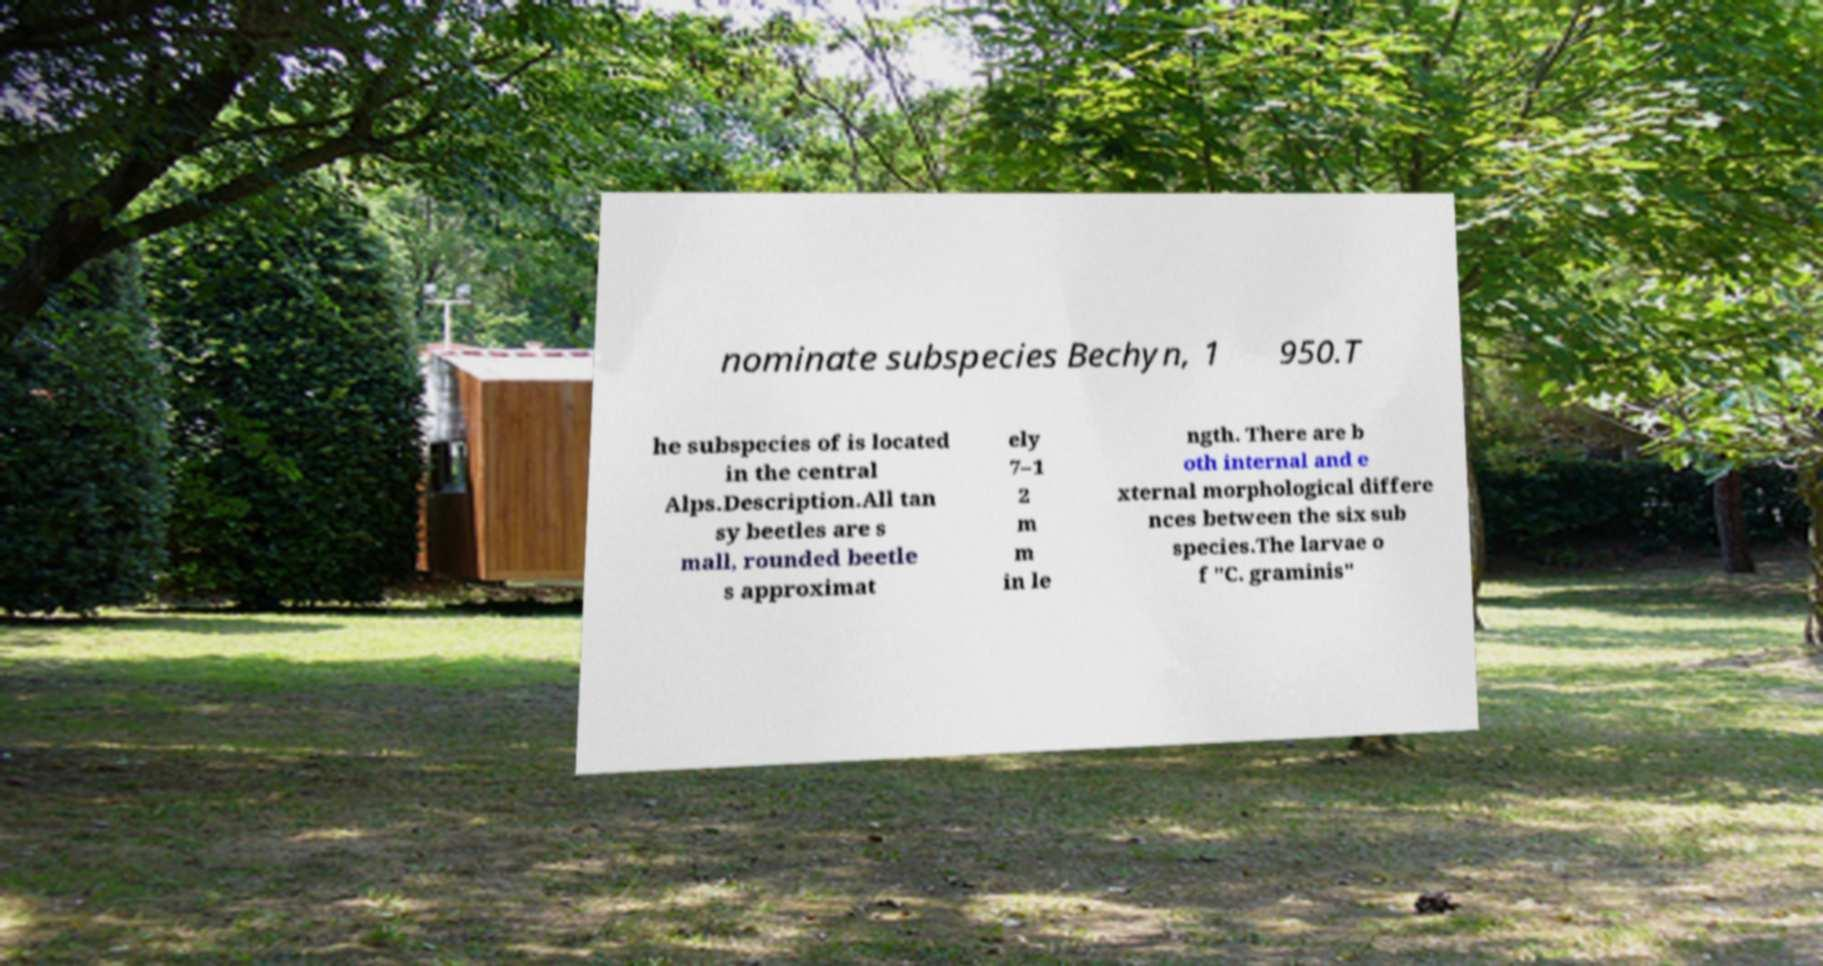Could you extract and type out the text from this image? nominate subspecies Bechyn, 1 950.T he subspecies of is located in the central Alps.Description.All tan sy beetles are s mall, rounded beetle s approximat ely 7–1 2 m m in le ngth. There are b oth internal and e xternal morphological differe nces between the six sub species.The larvae o f "C. graminis" 